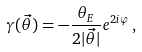Convert formula to latex. <formula><loc_0><loc_0><loc_500><loc_500>\gamma ( \vec { \theta } ) = - \frac { \theta _ { E } } { 2 | \vec { \theta } | } e ^ { 2 i \varphi } \, ,</formula> 